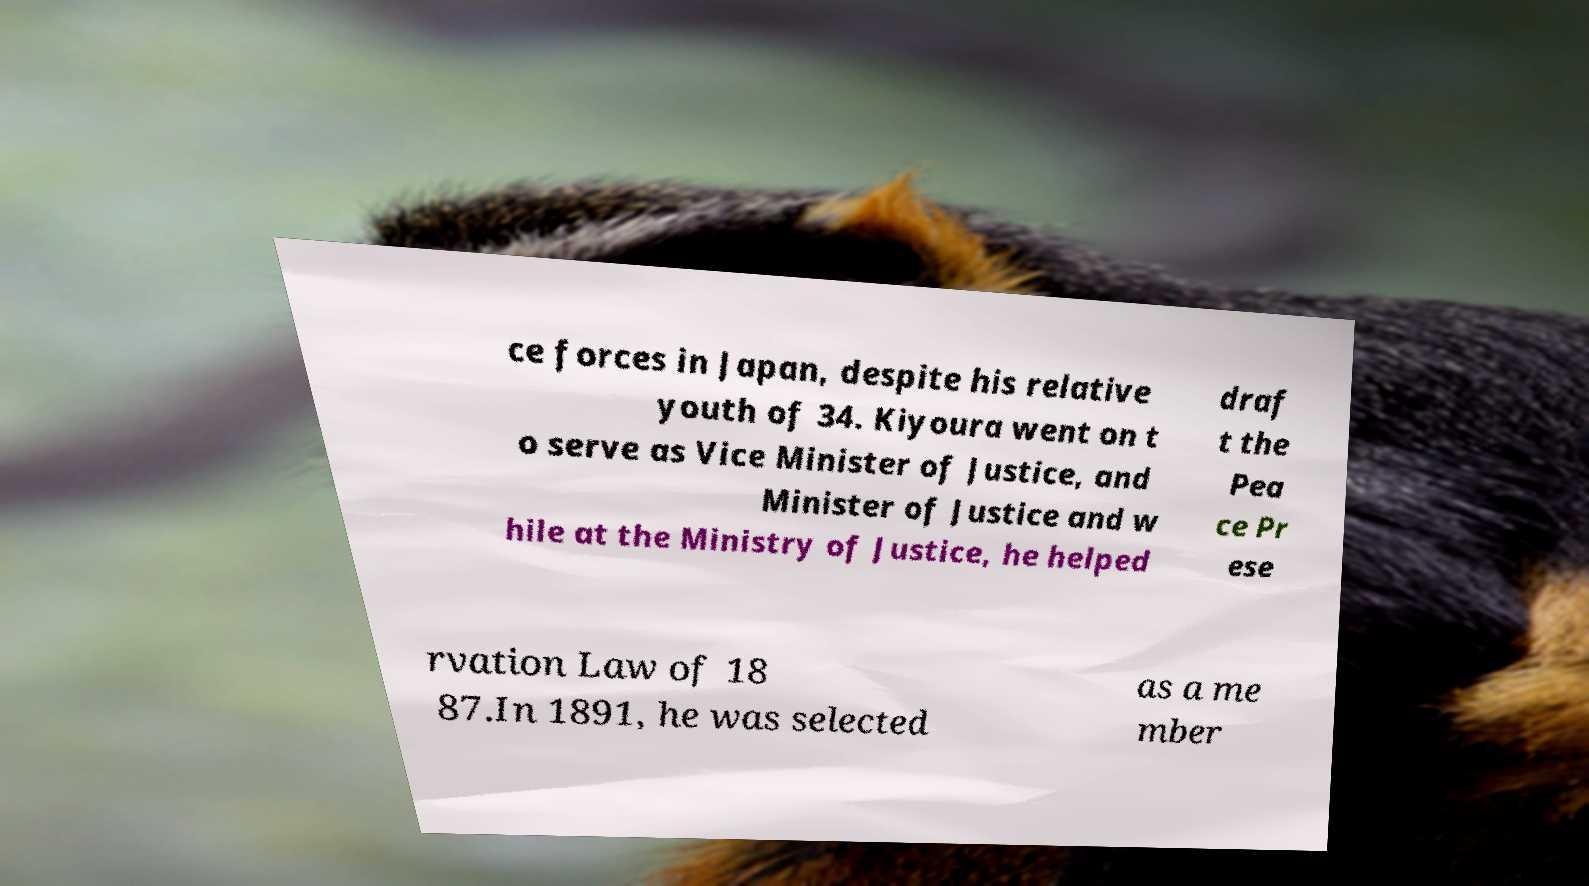For documentation purposes, I need the text within this image transcribed. Could you provide that? ce forces in Japan, despite his relative youth of 34. Kiyoura went on t o serve as Vice Minister of Justice, and Minister of Justice and w hile at the Ministry of Justice, he helped draf t the Pea ce Pr ese rvation Law of 18 87.In 1891, he was selected as a me mber 